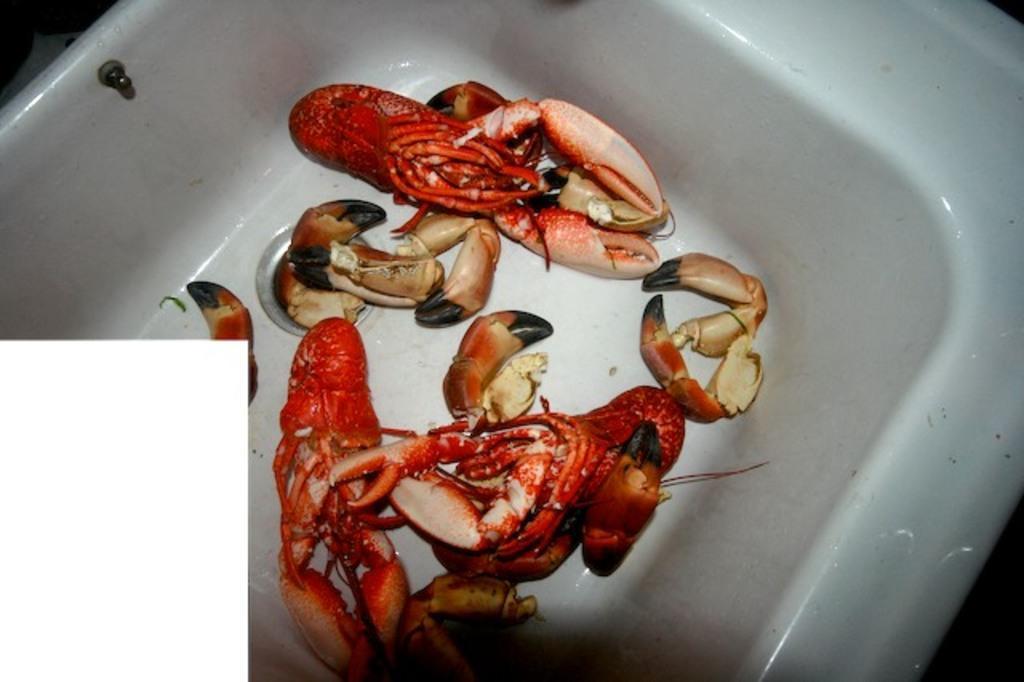Describe this image in one or two sentences. In this picture we can see a washbasin, there are some crabs present in this washbasin. 